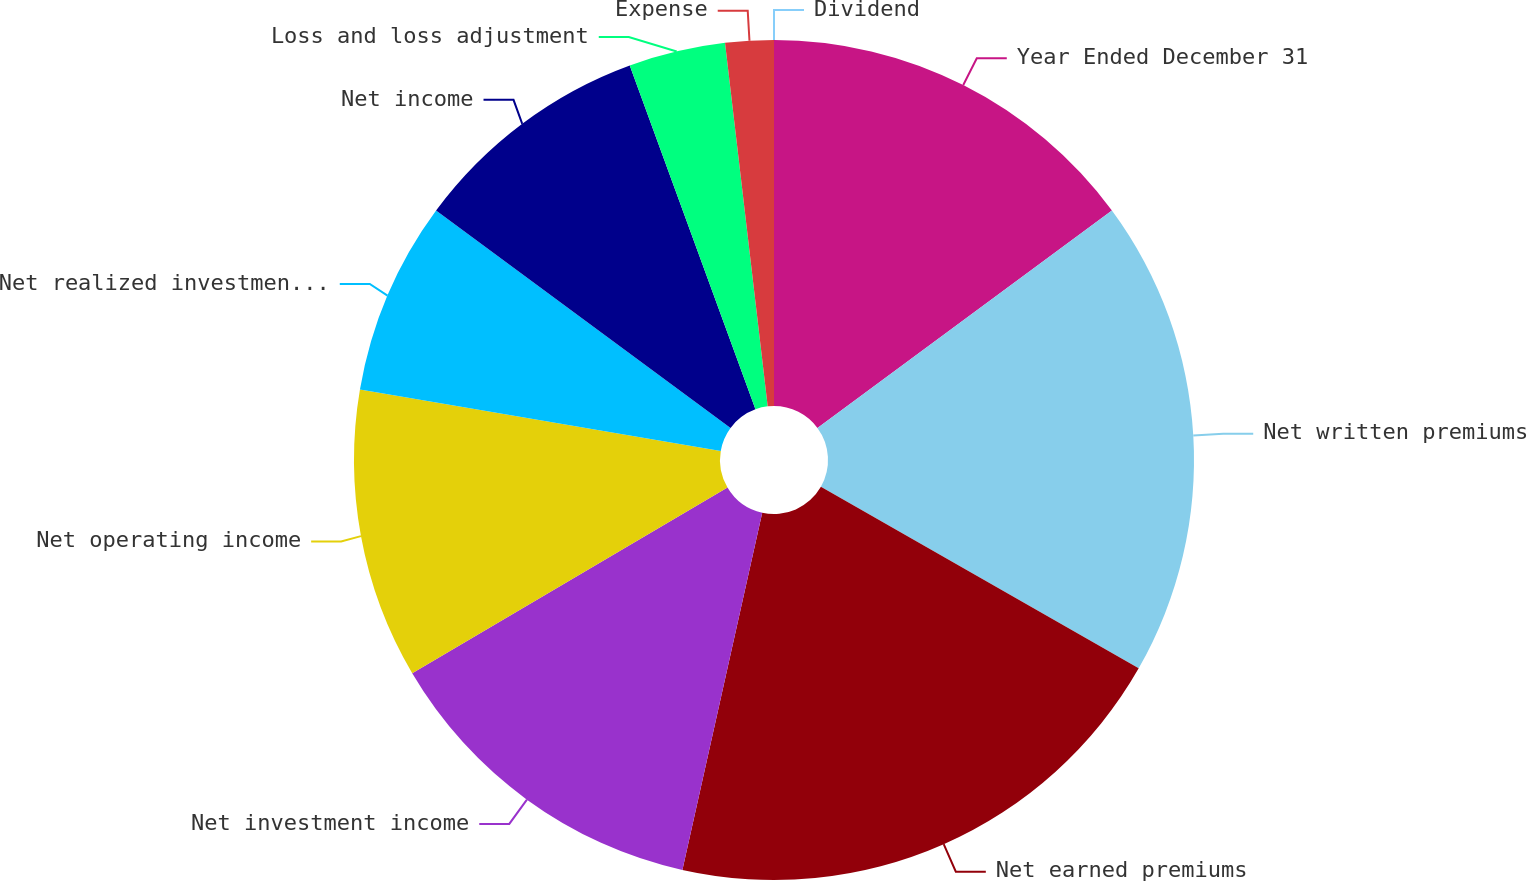Convert chart to OTSL. <chart><loc_0><loc_0><loc_500><loc_500><pie_chart><fcel>Year Ended December 31<fcel>Net written premiums<fcel>Net earned premiums<fcel>Net investment income<fcel>Net operating income<fcel>Net realized investment gains<fcel>Net income<fcel>Loss and loss adjustment<fcel>Expense<fcel>Dividend<nl><fcel>14.88%<fcel>18.38%<fcel>20.24%<fcel>13.02%<fcel>11.16%<fcel>7.44%<fcel>9.3%<fcel>3.72%<fcel>1.86%<fcel>0.0%<nl></chart> 